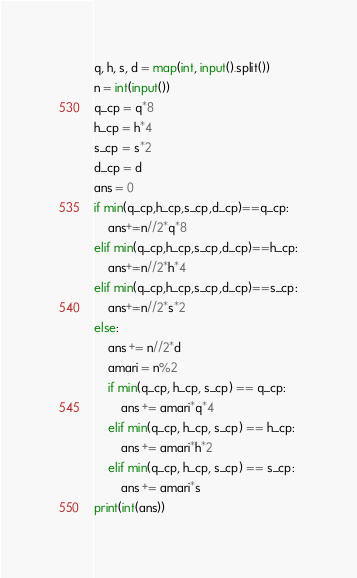Convert code to text. <code><loc_0><loc_0><loc_500><loc_500><_Python_>q, h, s, d = map(int, input().split())
n = int(input())
q_cp = q*8
h_cp = h*4
s_cp = s*2
d_cp = d
ans = 0
if min(q_cp,h_cp,s_cp,d_cp)==q_cp:
    ans+=n//2*q*8
elif min(q_cp,h_cp,s_cp,d_cp)==h_cp:
    ans+=n//2*h*4
elif min(q_cp,h_cp,s_cp,d_cp)==s_cp:
    ans+=n//2*s*2
else:
    ans += n//2*d
    amari = n%2
    if min(q_cp, h_cp, s_cp) == q_cp:
        ans += amari*q*4
    elif min(q_cp, h_cp, s_cp) == h_cp:
        ans += amari*h*2
    elif min(q_cp, h_cp, s_cp) == s_cp:
        ans += amari*s
print(int(ans))</code> 